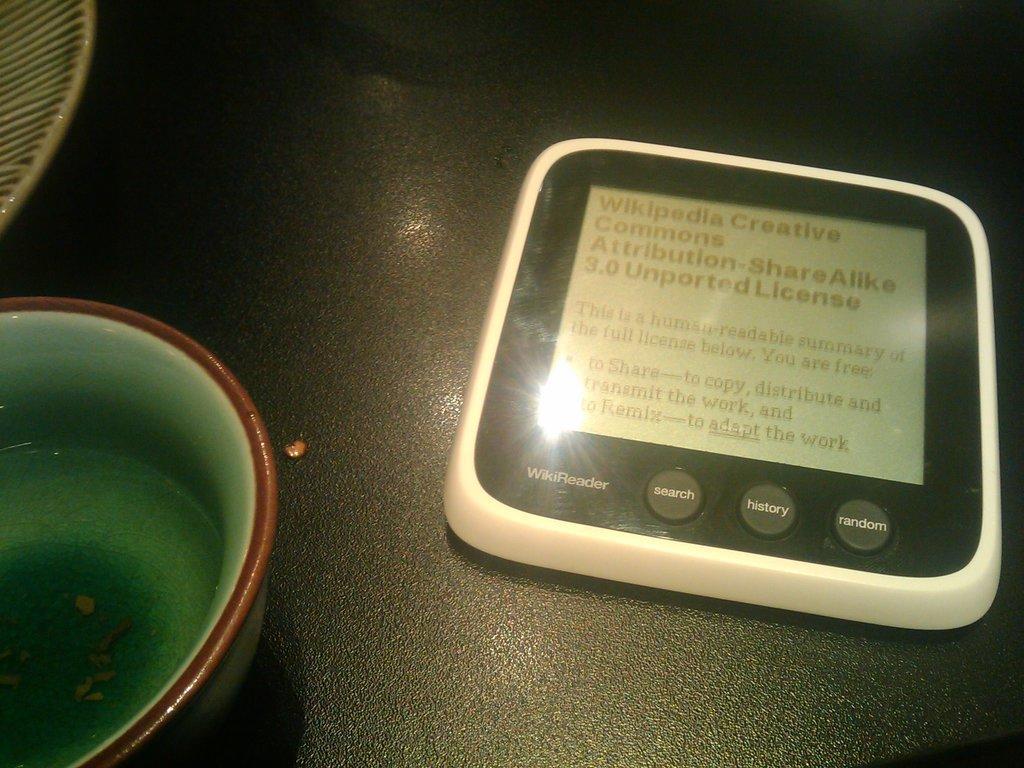In one or two sentences, can you explain what this image depicts? In this picture we can see a device, plate and a bowl with water in it and these all are placed on a surface. 